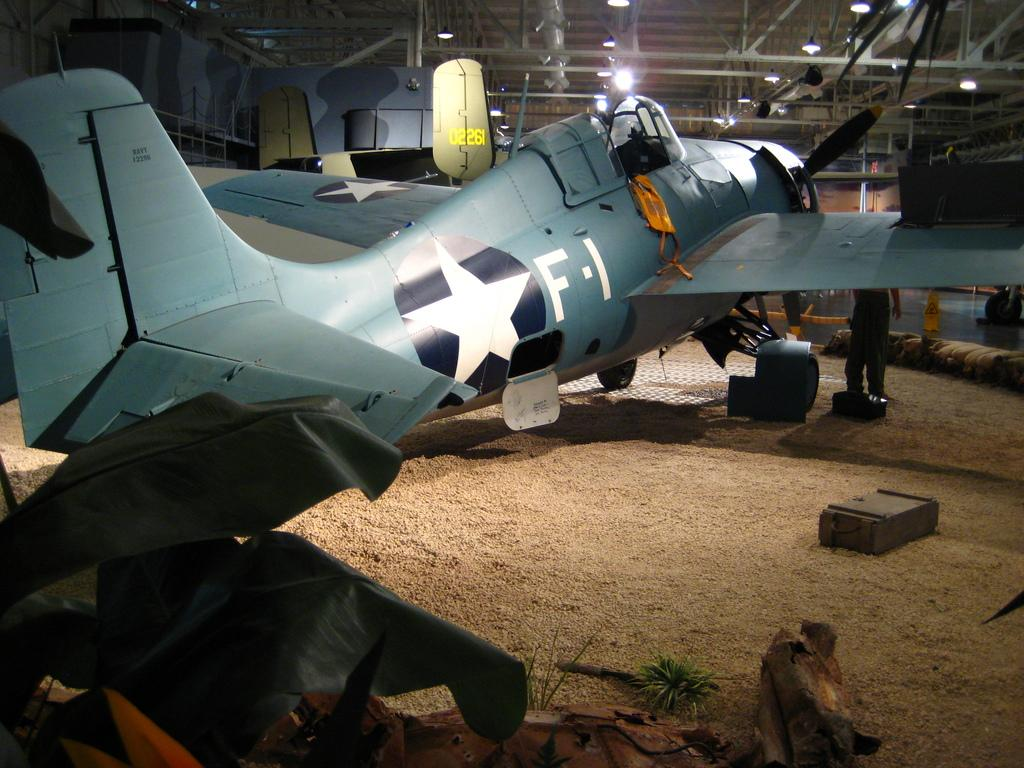What is the main subject of the picture? The main subject of the picture is an airplane. Can you describe the person in the image? There is a person standing on the ground in the image. What can be seen in the background of the picture? Lights and rods are visible in the background of the picture. How many legs does the airplane have in the image? Airplanes do not have legs; they have wings and a fuselage. The question is based on the absurd topic "legs" and is not relevant to the image. 